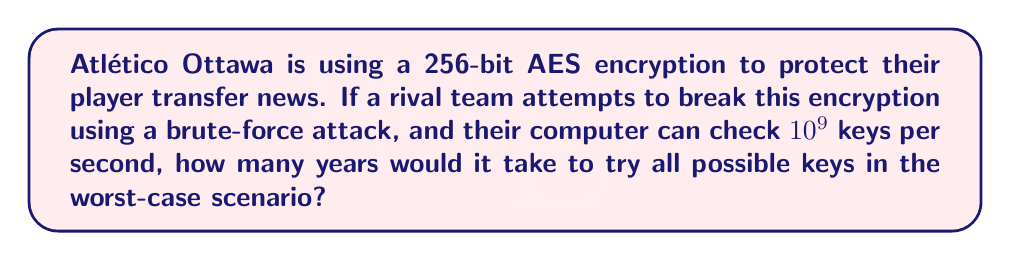Provide a solution to this math problem. Let's approach this step-by-step:

1) First, we need to calculate the total number of possible keys:
   For a 256-bit key, there are $2^{256}$ possible combinations.

2) Now, let's convert the computer's speed to keys per year:
   Keys per year = $10^9 \times 60 \times 60 \times 24 \times 365.25$
                 = $31,557,600,000,000,000$ keys/year
                 ≈ $3.1558 \times 10^{16}$ keys/year

3) To find the number of years, we divide the total number of keys by the keys checked per year:

   Years = $\frac{2^{256}}{3.1558 \times 10^{16}}$

4) Let's calculate this:
   $2^{256}$ ≈ $1.1579 \times 10^{77}$

   Years = $\frac{1.1579 \times 10^{77}}{3.1558 \times 10^{16}}$
         ≈ $3.6691 \times 10^{60}$ years

5) This number is astronomically large. To put it in perspective, the current age of the universe is estimated to be about $13.8 \times 10^9$ years.
Answer: $3.6691 \times 10^{60}$ years 